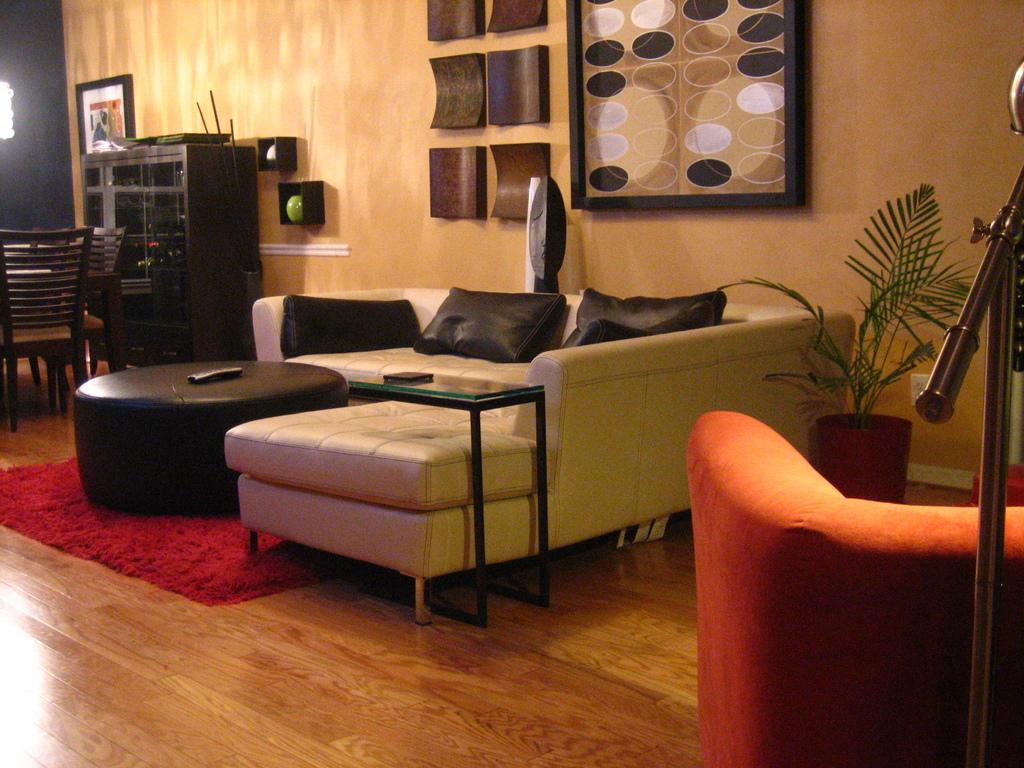What type of structure can be seen in the image? There is a wall in the image. What is hanging on the wall in the image? There is a photo frame in the image. What piece of furniture is present in the image for hanging items? There is a rack in the image. What type of seating is available in the image? There are chairs and sofas in the image. What type of greenery is present in the image? There is a plant on the right side of the image. What device is present in the image for controlling electronic devices? There is a remote in the image. What type of game is being played in the image? There is no game being played in the image. What part of the body is used to control the remote in the image? The image does not show anyone using the remote, so it is not possible to determine which part of the body would be used to control it. 